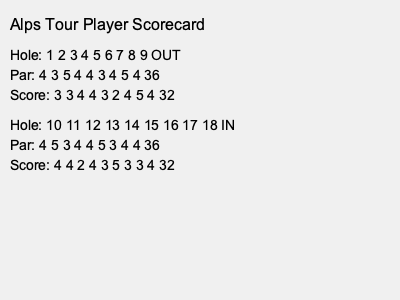Based on the scorecard shown, what was the player's total score for the round, and how many strokes under par did they finish? To solve this question, we need to follow these steps:

1. Calculate the total par for the course:
   Front nine (OUT) par: 36
   Back nine (IN) par: 36
   Total par = 36 + 36 = 72

2. Calculate the player's total score:
   Front nine (OUT) score: 32
   Back nine (IN) score: 32
   Total score = 32 + 32 = 64

3. Calculate the difference between the player's score and par:
   Strokes under par = Total par - Player's total score
   Strokes under par = 72 - 64 = 8

Therefore, the player's total score for the round was 64, and they finished 8 strokes under par.
Answer: 64 strokes, 8 under par 